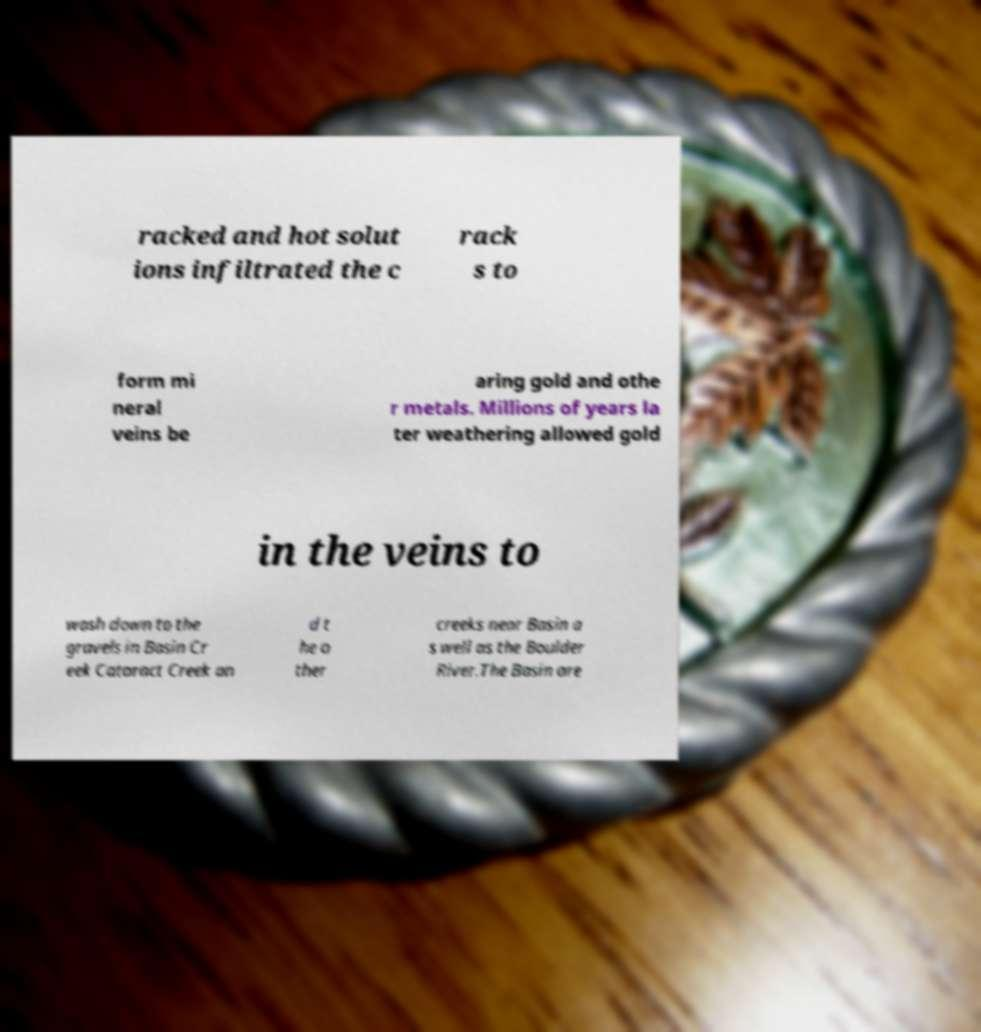There's text embedded in this image that I need extracted. Can you transcribe it verbatim? racked and hot solut ions infiltrated the c rack s to form mi neral veins be aring gold and othe r metals. Millions of years la ter weathering allowed gold in the veins to wash down to the gravels in Basin Cr eek Cataract Creek an d t he o ther creeks near Basin a s well as the Boulder River.The Basin are 